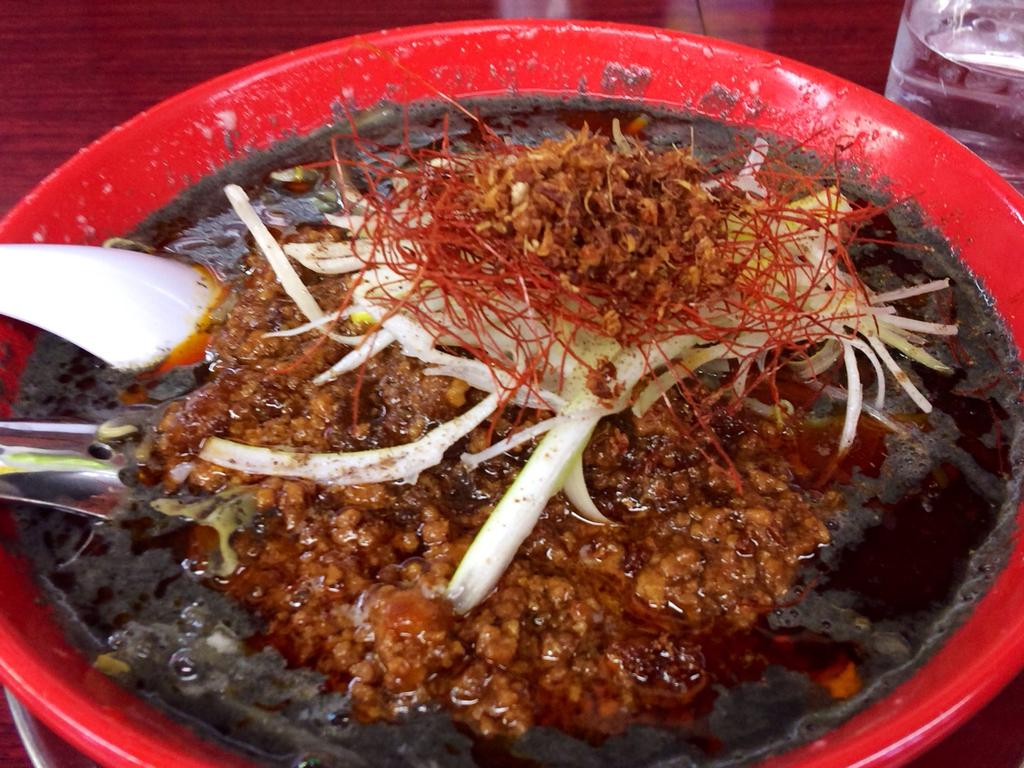What is present in the image related to eating? There is food and a spoon in the image. How are the food and spoon arranged in the image? The food and spoon are placed in a bowl. Where is the bowl located in the image? The bowl is kept on a surface. What else can be seen in the background of the image? There is a bottle in the background of the image. What type of circle is visible in the image? There is no circle present in the image. Can you describe the car in the image? There is no car present in the image. 